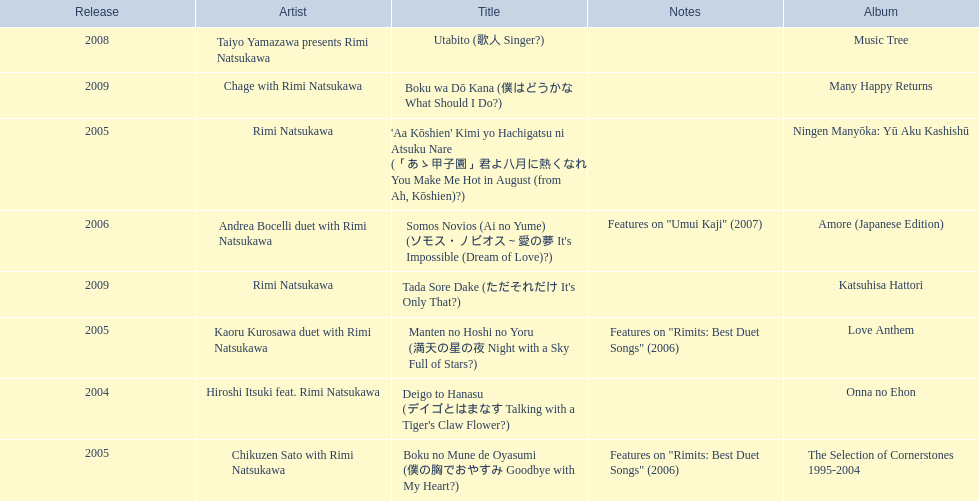How many titles have only one artist? 2. 